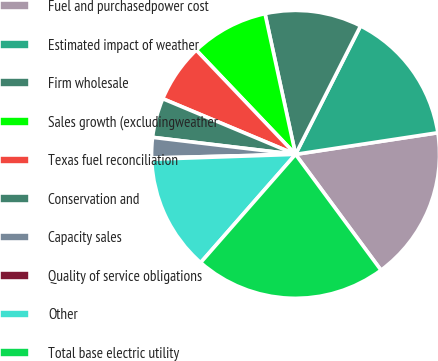<chart> <loc_0><loc_0><loc_500><loc_500><pie_chart><fcel>Fuel and purchasedpower cost<fcel>Estimated impact of weather<fcel>Firm wholesale<fcel>Sales growth (excludingweather<fcel>Texas fuel reconciliation<fcel>Conservation and<fcel>Capacity sales<fcel>Quality of service obligations<fcel>Other<fcel>Total base electric utility<nl><fcel>17.28%<fcel>15.14%<fcel>10.86%<fcel>8.71%<fcel>6.57%<fcel>4.43%<fcel>2.29%<fcel>0.14%<fcel>13.0%<fcel>21.57%<nl></chart> 